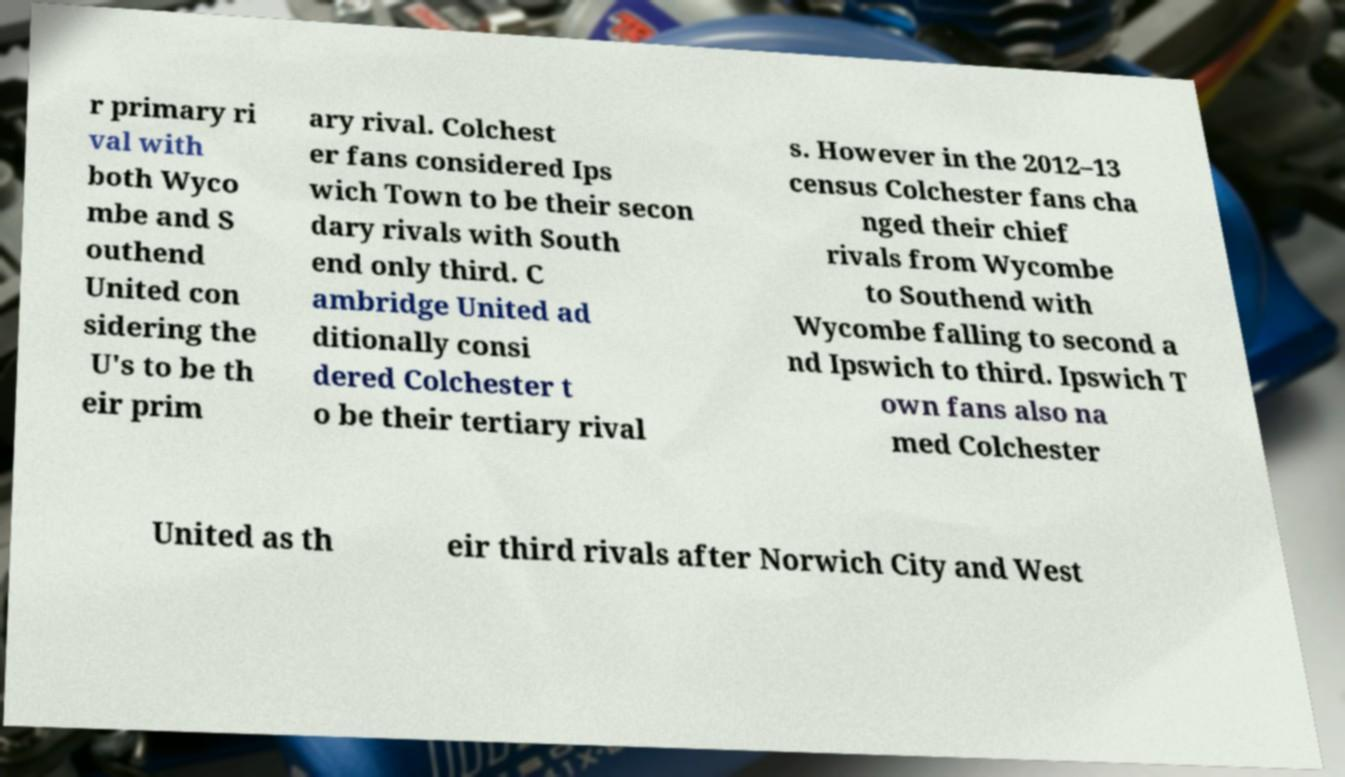What messages or text are displayed in this image? I need them in a readable, typed format. r primary ri val with both Wyco mbe and S outhend United con sidering the U's to be th eir prim ary rival. Colchest er fans considered Ips wich Town to be their secon dary rivals with South end only third. C ambridge United ad ditionally consi dered Colchester t o be their tertiary rival s. However in the 2012–13 census Colchester fans cha nged their chief rivals from Wycombe to Southend with Wycombe falling to second a nd Ipswich to third. Ipswich T own fans also na med Colchester United as th eir third rivals after Norwich City and West 